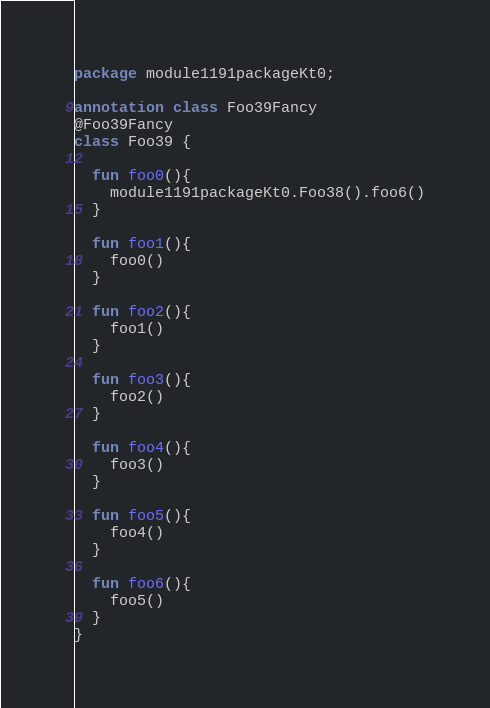<code> <loc_0><loc_0><loc_500><loc_500><_Kotlin_>package module1191packageKt0;

annotation class Foo39Fancy
@Foo39Fancy
class Foo39 {

  fun foo0(){
    module1191packageKt0.Foo38().foo6()
  }

  fun foo1(){
    foo0()
  }

  fun foo2(){
    foo1()
  }

  fun foo3(){
    foo2()
  }

  fun foo4(){
    foo3()
  }

  fun foo5(){
    foo4()
  }

  fun foo6(){
    foo5()
  }
}</code> 